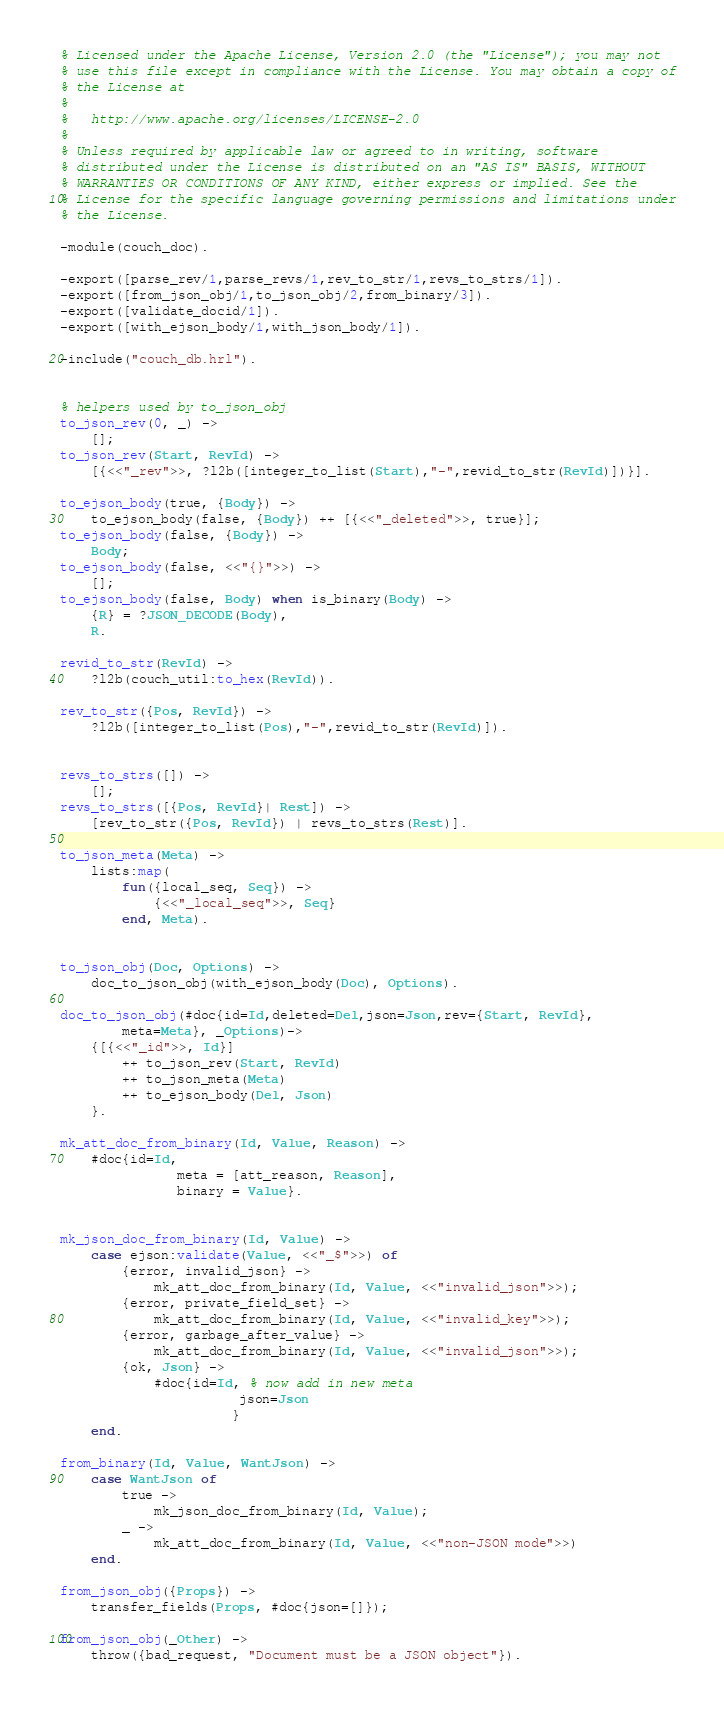<code> <loc_0><loc_0><loc_500><loc_500><_Erlang_>% Licensed under the Apache License, Version 2.0 (the "License"); you may not
% use this file except in compliance with the License. You may obtain a copy of
% the License at
%
%   http://www.apache.org/licenses/LICENSE-2.0
%
% Unless required by applicable law or agreed to in writing, software
% distributed under the License is distributed on an "AS IS" BASIS, WITHOUT
% WARRANTIES OR CONDITIONS OF ANY KIND, either express or implied. See the
% License for the specific language governing permissions and limitations under
% the License.

-module(couch_doc).

-export([parse_rev/1,parse_revs/1,rev_to_str/1,revs_to_strs/1]).
-export([from_json_obj/1,to_json_obj/2,from_binary/3]).
-export([validate_docid/1]).
-export([with_ejson_body/1,with_json_body/1]).

-include("couch_db.hrl").


% helpers used by to_json_obj
to_json_rev(0, _) ->
    [];
to_json_rev(Start, RevId) ->
    [{<<"_rev">>, ?l2b([integer_to_list(Start),"-",revid_to_str(RevId)])}].

to_ejson_body(true, {Body}) ->
    to_ejson_body(false, {Body}) ++ [{<<"_deleted">>, true}];
to_ejson_body(false, {Body}) ->
    Body;
to_ejson_body(false, <<"{}">>) ->
    [];
to_ejson_body(false, Body) when is_binary(Body) ->
    {R} = ?JSON_DECODE(Body),
    R.

revid_to_str(RevId) ->
    ?l2b(couch_util:to_hex(RevId)).

rev_to_str({Pos, RevId}) ->
    ?l2b([integer_to_list(Pos),"-",revid_to_str(RevId)]).
                    
                    
revs_to_strs([]) ->
    [];
revs_to_strs([{Pos, RevId}| Rest]) ->
    [rev_to_str({Pos, RevId}) | revs_to_strs(Rest)].

to_json_meta(Meta) ->
    lists:map(
        fun({local_seq, Seq}) ->
            {<<"_local_seq">>, Seq}
        end, Meta).


to_json_obj(Doc, Options) ->
    doc_to_json_obj(with_ejson_body(Doc), Options).

doc_to_json_obj(#doc{id=Id,deleted=Del,json=Json,rev={Start, RevId},
        meta=Meta}, _Options)->
    {[{<<"_id">>, Id}]
        ++ to_json_rev(Start, RevId)
        ++ to_json_meta(Meta)
        ++ to_ejson_body(Del, Json)
    }.

mk_att_doc_from_binary(Id, Value, Reason) ->
    #doc{id=Id,
               meta = [att_reason, Reason],
               binary = Value}.


mk_json_doc_from_binary(Id, Value) ->
    case ejson:validate(Value, <<"_$">>) of
        {error, invalid_json} ->
            mk_att_doc_from_binary(Id, Value, <<"invalid_json">>);
        {error, private_field_set} ->
            mk_att_doc_from_binary(Id, Value, <<"invalid_key">>);
        {error, garbage_after_value} ->
            mk_att_doc_from_binary(Id, Value, <<"invalid_json">>);
        {ok, Json} ->
            #doc{id=Id, % now add in new meta
                       json=Json
                      }
    end.

from_binary(Id, Value, WantJson) ->
    case WantJson of
        true ->
            mk_json_doc_from_binary(Id, Value);
        _ ->
            mk_att_doc_from_binary(Id, Value, <<"non-JSON mode">>)
    end.

from_json_obj({Props}) ->
    transfer_fields(Props, #doc{json=[]});

from_json_obj(_Other) ->
    throw({bad_request, "Document must be a JSON object"}).
</code> 